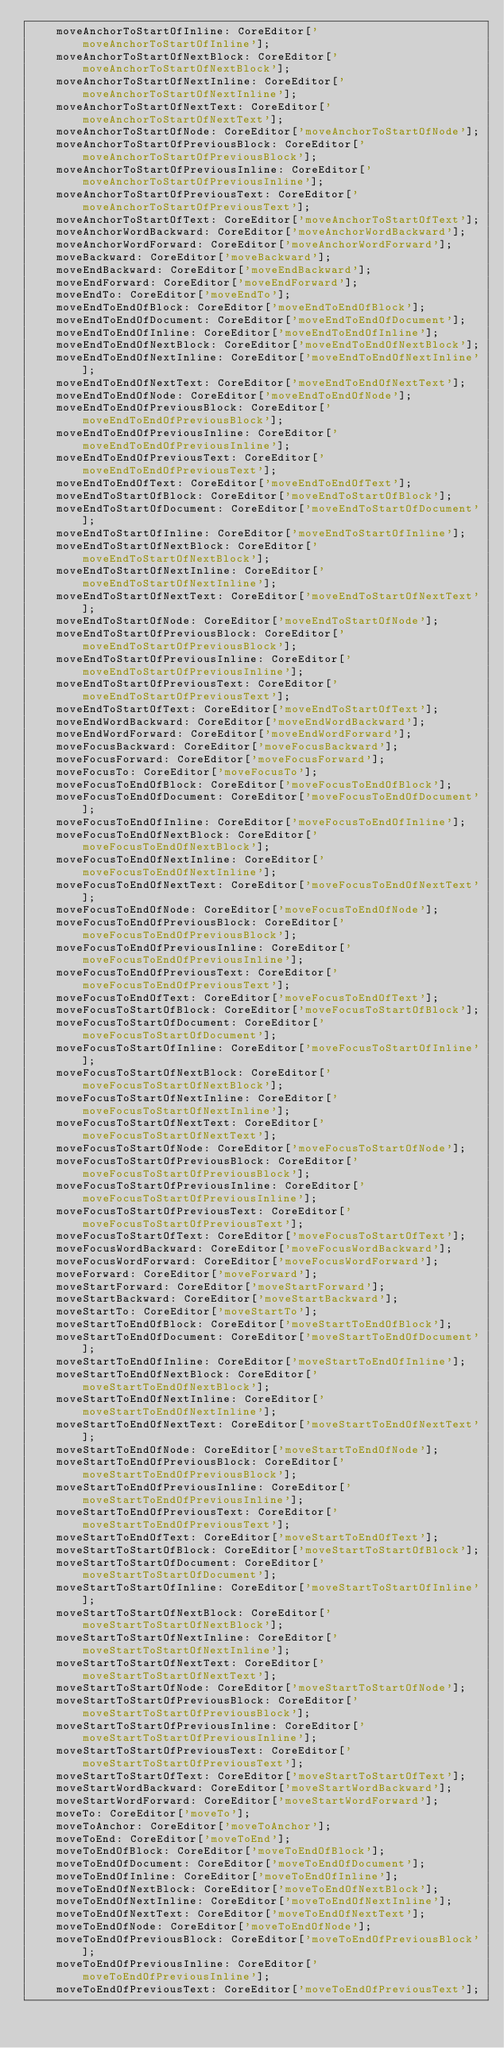<code> <loc_0><loc_0><loc_500><loc_500><_TypeScript_>    moveAnchorToStartOfInline: CoreEditor['moveAnchorToStartOfInline'];
    moveAnchorToStartOfNextBlock: CoreEditor['moveAnchorToStartOfNextBlock'];
    moveAnchorToStartOfNextInline: CoreEditor['moveAnchorToStartOfNextInline'];
    moveAnchorToStartOfNextText: CoreEditor['moveAnchorToStartOfNextText'];
    moveAnchorToStartOfNode: CoreEditor['moveAnchorToStartOfNode'];
    moveAnchorToStartOfPreviousBlock: CoreEditor['moveAnchorToStartOfPreviousBlock'];
    moveAnchorToStartOfPreviousInline: CoreEditor['moveAnchorToStartOfPreviousInline'];
    moveAnchorToStartOfPreviousText: CoreEditor['moveAnchorToStartOfPreviousText'];
    moveAnchorToStartOfText: CoreEditor['moveAnchorToStartOfText'];
    moveAnchorWordBackward: CoreEditor['moveAnchorWordBackward'];
    moveAnchorWordForward: CoreEditor['moveAnchorWordForward'];
    moveBackward: CoreEditor['moveBackward'];
    moveEndBackward: CoreEditor['moveEndBackward'];
    moveEndForward: CoreEditor['moveEndForward'];
    moveEndTo: CoreEditor['moveEndTo'];
    moveEndToEndOfBlock: CoreEditor['moveEndToEndOfBlock'];
    moveEndToEndOfDocument: CoreEditor['moveEndToEndOfDocument'];
    moveEndToEndOfInline: CoreEditor['moveEndToEndOfInline'];
    moveEndToEndOfNextBlock: CoreEditor['moveEndToEndOfNextBlock'];
    moveEndToEndOfNextInline: CoreEditor['moveEndToEndOfNextInline'];
    moveEndToEndOfNextText: CoreEditor['moveEndToEndOfNextText'];
    moveEndToEndOfNode: CoreEditor['moveEndToEndOfNode'];
    moveEndToEndOfPreviousBlock: CoreEditor['moveEndToEndOfPreviousBlock'];
    moveEndToEndOfPreviousInline: CoreEditor['moveEndToEndOfPreviousInline'];
    moveEndToEndOfPreviousText: CoreEditor['moveEndToEndOfPreviousText'];
    moveEndToEndOfText: CoreEditor['moveEndToEndOfText'];
    moveEndToStartOfBlock: CoreEditor['moveEndToStartOfBlock'];
    moveEndToStartOfDocument: CoreEditor['moveEndToStartOfDocument'];
    moveEndToStartOfInline: CoreEditor['moveEndToStartOfInline'];
    moveEndToStartOfNextBlock: CoreEditor['moveEndToStartOfNextBlock'];
    moveEndToStartOfNextInline: CoreEditor['moveEndToStartOfNextInline'];
    moveEndToStartOfNextText: CoreEditor['moveEndToStartOfNextText'];
    moveEndToStartOfNode: CoreEditor['moveEndToStartOfNode'];
    moveEndToStartOfPreviousBlock: CoreEditor['moveEndToStartOfPreviousBlock'];
    moveEndToStartOfPreviousInline: CoreEditor['moveEndToStartOfPreviousInline'];
    moveEndToStartOfPreviousText: CoreEditor['moveEndToStartOfPreviousText'];
    moveEndToStartOfText: CoreEditor['moveEndToStartOfText'];
    moveEndWordBackward: CoreEditor['moveEndWordBackward'];
    moveEndWordForward: CoreEditor['moveEndWordForward'];
    moveFocusBackward: CoreEditor['moveFocusBackward'];
    moveFocusForward: CoreEditor['moveFocusForward'];
    moveFocusTo: CoreEditor['moveFocusTo'];
    moveFocusToEndOfBlock: CoreEditor['moveFocusToEndOfBlock'];
    moveFocusToEndOfDocument: CoreEditor['moveFocusToEndOfDocument'];
    moveFocusToEndOfInline: CoreEditor['moveFocusToEndOfInline'];
    moveFocusToEndOfNextBlock: CoreEditor['moveFocusToEndOfNextBlock'];
    moveFocusToEndOfNextInline: CoreEditor['moveFocusToEndOfNextInline'];
    moveFocusToEndOfNextText: CoreEditor['moveFocusToEndOfNextText'];
    moveFocusToEndOfNode: CoreEditor['moveFocusToEndOfNode'];
    moveFocusToEndOfPreviousBlock: CoreEditor['moveFocusToEndOfPreviousBlock'];
    moveFocusToEndOfPreviousInline: CoreEditor['moveFocusToEndOfPreviousInline'];
    moveFocusToEndOfPreviousText: CoreEditor['moveFocusToEndOfPreviousText'];
    moveFocusToEndOfText: CoreEditor['moveFocusToEndOfText'];
    moveFocusToStartOfBlock: CoreEditor['moveFocusToStartOfBlock'];
    moveFocusToStartOfDocument: CoreEditor['moveFocusToStartOfDocument'];
    moveFocusToStartOfInline: CoreEditor['moveFocusToStartOfInline'];
    moveFocusToStartOfNextBlock: CoreEditor['moveFocusToStartOfNextBlock'];
    moveFocusToStartOfNextInline: CoreEditor['moveFocusToStartOfNextInline'];
    moveFocusToStartOfNextText: CoreEditor['moveFocusToStartOfNextText'];
    moveFocusToStartOfNode: CoreEditor['moveFocusToStartOfNode'];
    moveFocusToStartOfPreviousBlock: CoreEditor['moveFocusToStartOfPreviousBlock'];
    moveFocusToStartOfPreviousInline: CoreEditor['moveFocusToStartOfPreviousInline'];
    moveFocusToStartOfPreviousText: CoreEditor['moveFocusToStartOfPreviousText'];
    moveFocusToStartOfText: CoreEditor['moveFocusToStartOfText'];
    moveFocusWordBackward: CoreEditor['moveFocusWordBackward'];
    moveFocusWordForward: CoreEditor['moveFocusWordForward'];
    moveForward: CoreEditor['moveForward'];
    moveStartForward: CoreEditor['moveStartForward'];
    moveStartBackward: CoreEditor['moveStartBackward'];
    moveStartTo: CoreEditor['moveStartTo'];
    moveStartToEndOfBlock: CoreEditor['moveStartToEndOfBlock'];
    moveStartToEndOfDocument: CoreEditor['moveStartToEndOfDocument'];
    moveStartToEndOfInline: CoreEditor['moveStartToEndOfInline'];
    moveStartToEndOfNextBlock: CoreEditor['moveStartToEndOfNextBlock'];
    moveStartToEndOfNextInline: CoreEditor['moveStartToEndOfNextInline'];
    moveStartToEndOfNextText: CoreEditor['moveStartToEndOfNextText'];
    moveStartToEndOfNode: CoreEditor['moveStartToEndOfNode'];
    moveStartToEndOfPreviousBlock: CoreEditor['moveStartToEndOfPreviousBlock'];
    moveStartToEndOfPreviousInline: CoreEditor['moveStartToEndOfPreviousInline'];
    moveStartToEndOfPreviousText: CoreEditor['moveStartToEndOfPreviousText'];
    moveStartToEndOfText: CoreEditor['moveStartToEndOfText'];
    moveStartToStartOfBlock: CoreEditor['moveStartToStartOfBlock'];
    moveStartToStartOfDocument: CoreEditor['moveStartToStartOfDocument'];
    moveStartToStartOfInline: CoreEditor['moveStartToStartOfInline'];
    moveStartToStartOfNextBlock: CoreEditor['moveStartToStartOfNextBlock'];
    moveStartToStartOfNextInline: CoreEditor['moveStartToStartOfNextInline'];
    moveStartToStartOfNextText: CoreEditor['moveStartToStartOfNextText'];
    moveStartToStartOfNode: CoreEditor['moveStartToStartOfNode'];
    moveStartToStartOfPreviousBlock: CoreEditor['moveStartToStartOfPreviousBlock'];
    moveStartToStartOfPreviousInline: CoreEditor['moveStartToStartOfPreviousInline'];
    moveStartToStartOfPreviousText: CoreEditor['moveStartToStartOfPreviousText'];
    moveStartToStartOfText: CoreEditor['moveStartToStartOfText'];
    moveStartWordBackward: CoreEditor['moveStartWordBackward'];
    moveStartWordForward: CoreEditor['moveStartWordForward'];
    moveTo: CoreEditor['moveTo'];
    moveToAnchor: CoreEditor['moveToAnchor'];
    moveToEnd: CoreEditor['moveToEnd'];
    moveToEndOfBlock: CoreEditor['moveToEndOfBlock'];
    moveToEndOfDocument: CoreEditor['moveToEndOfDocument'];
    moveToEndOfInline: CoreEditor['moveToEndOfInline'];
    moveToEndOfNextBlock: CoreEditor['moveToEndOfNextBlock'];
    moveToEndOfNextInline: CoreEditor['moveToEndOfNextInline'];
    moveToEndOfNextText: CoreEditor['moveToEndOfNextText'];
    moveToEndOfNode: CoreEditor['moveToEndOfNode'];
    moveToEndOfPreviousBlock: CoreEditor['moveToEndOfPreviousBlock'];
    moveToEndOfPreviousInline: CoreEditor['moveToEndOfPreviousInline'];
    moveToEndOfPreviousText: CoreEditor['moveToEndOfPreviousText'];</code> 